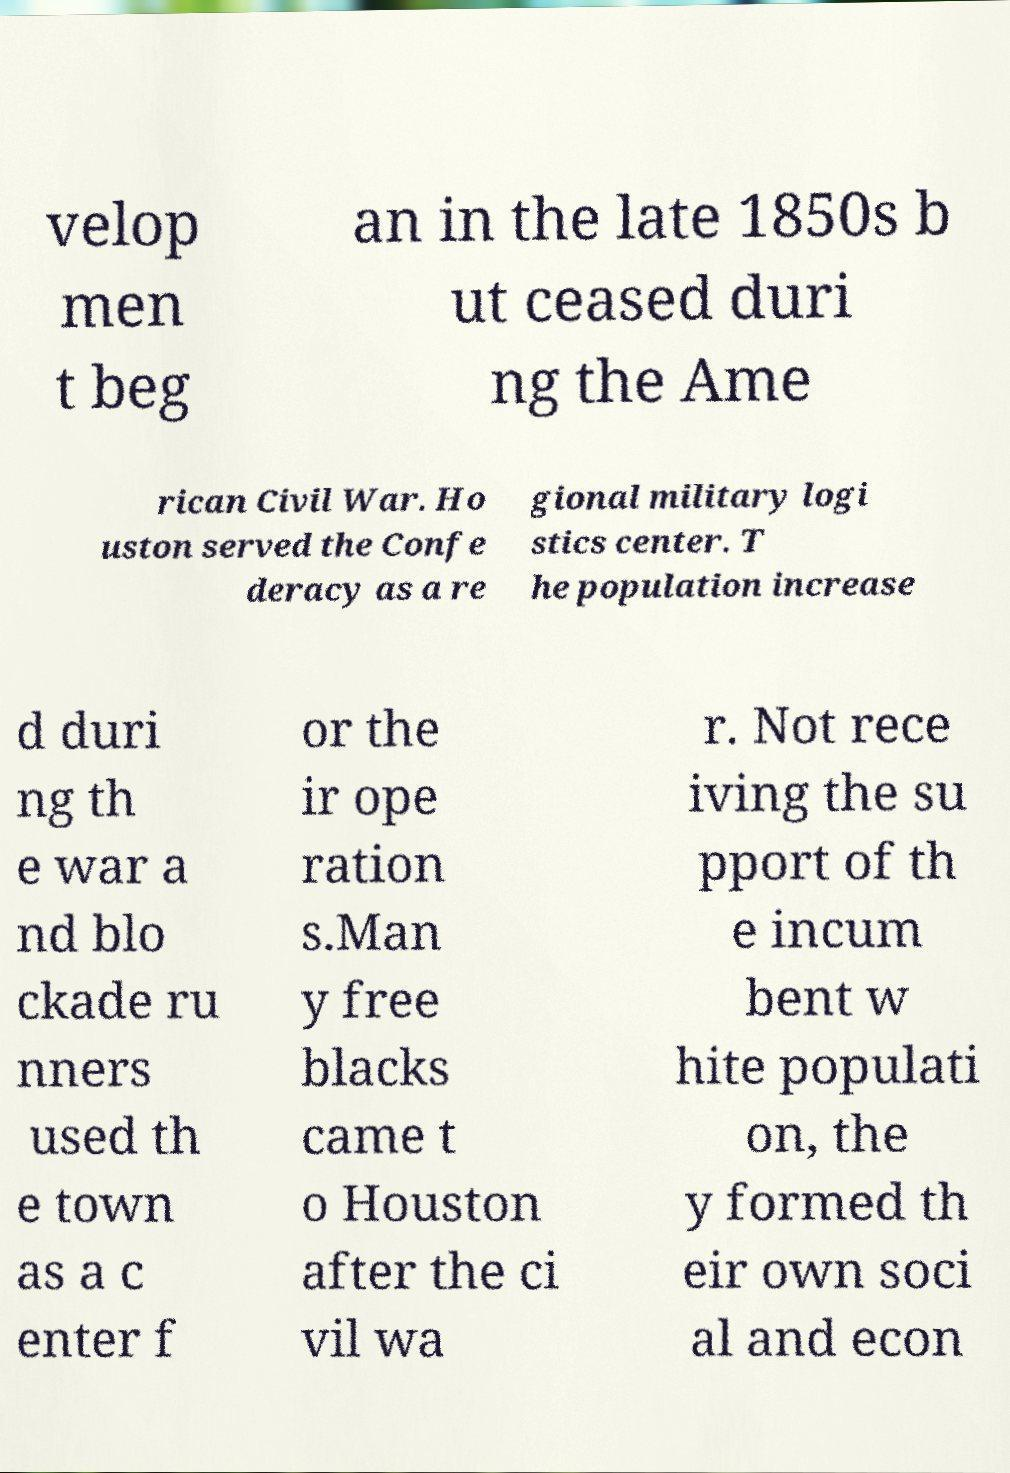Please read and relay the text visible in this image. What does it say? velop men t beg an in the late 1850s b ut ceased duri ng the Ame rican Civil War. Ho uston served the Confe deracy as a re gional military logi stics center. T he population increase d duri ng th e war a nd blo ckade ru nners used th e town as a c enter f or the ir ope ration s.Man y free blacks came t o Houston after the ci vil wa r. Not rece iving the su pport of th e incum bent w hite populati on, the y formed th eir own soci al and econ 